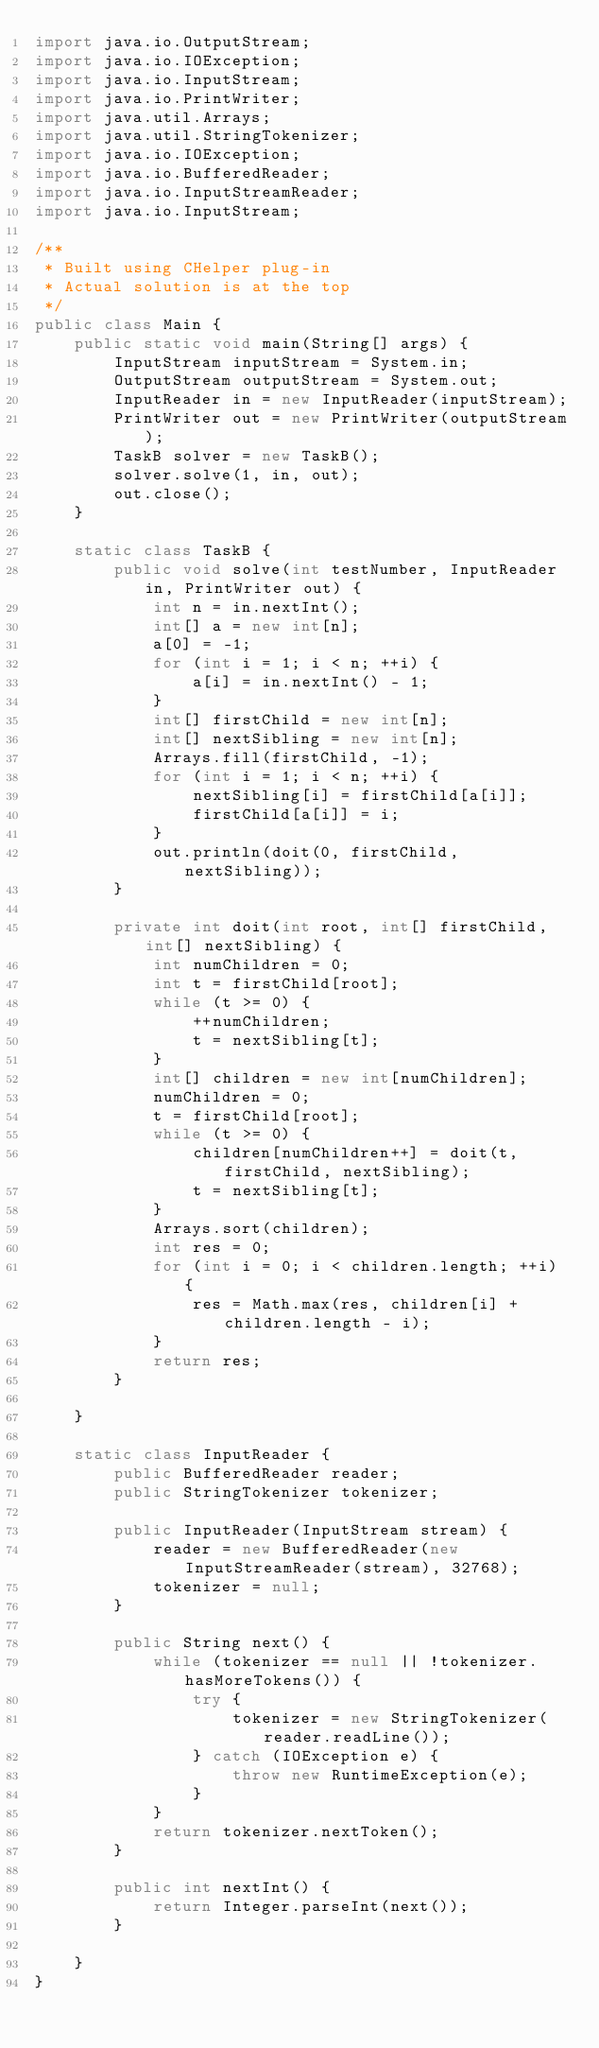Convert code to text. <code><loc_0><loc_0><loc_500><loc_500><_Java_>import java.io.OutputStream;
import java.io.IOException;
import java.io.InputStream;
import java.io.PrintWriter;
import java.util.Arrays;
import java.util.StringTokenizer;
import java.io.IOException;
import java.io.BufferedReader;
import java.io.InputStreamReader;
import java.io.InputStream;

/**
 * Built using CHelper plug-in
 * Actual solution is at the top
 */
public class Main {
    public static void main(String[] args) {
        InputStream inputStream = System.in;
        OutputStream outputStream = System.out;
        InputReader in = new InputReader(inputStream);
        PrintWriter out = new PrintWriter(outputStream);
        TaskB solver = new TaskB();
        solver.solve(1, in, out);
        out.close();
    }

    static class TaskB {
        public void solve(int testNumber, InputReader in, PrintWriter out) {
            int n = in.nextInt();
            int[] a = new int[n];
            a[0] = -1;
            for (int i = 1; i < n; ++i) {
                a[i] = in.nextInt() - 1;
            }
            int[] firstChild = new int[n];
            int[] nextSibling = new int[n];
            Arrays.fill(firstChild, -1);
            for (int i = 1; i < n; ++i) {
                nextSibling[i] = firstChild[a[i]];
                firstChild[a[i]] = i;
            }
            out.println(doit(0, firstChild, nextSibling));
        }

        private int doit(int root, int[] firstChild, int[] nextSibling) {
            int numChildren = 0;
            int t = firstChild[root];
            while (t >= 0) {
                ++numChildren;
                t = nextSibling[t];
            }
            int[] children = new int[numChildren];
            numChildren = 0;
            t = firstChild[root];
            while (t >= 0) {
                children[numChildren++] = doit(t, firstChild, nextSibling);
                t = nextSibling[t];
            }
            Arrays.sort(children);
            int res = 0;
            for (int i = 0; i < children.length; ++i) {
                res = Math.max(res, children[i] + children.length - i);
            }
            return res;
        }

    }

    static class InputReader {
        public BufferedReader reader;
        public StringTokenizer tokenizer;

        public InputReader(InputStream stream) {
            reader = new BufferedReader(new InputStreamReader(stream), 32768);
            tokenizer = null;
        }

        public String next() {
            while (tokenizer == null || !tokenizer.hasMoreTokens()) {
                try {
                    tokenizer = new StringTokenizer(reader.readLine());
                } catch (IOException e) {
                    throw new RuntimeException(e);
                }
            }
            return tokenizer.nextToken();
        }

        public int nextInt() {
            return Integer.parseInt(next());
        }

    }
}

</code> 